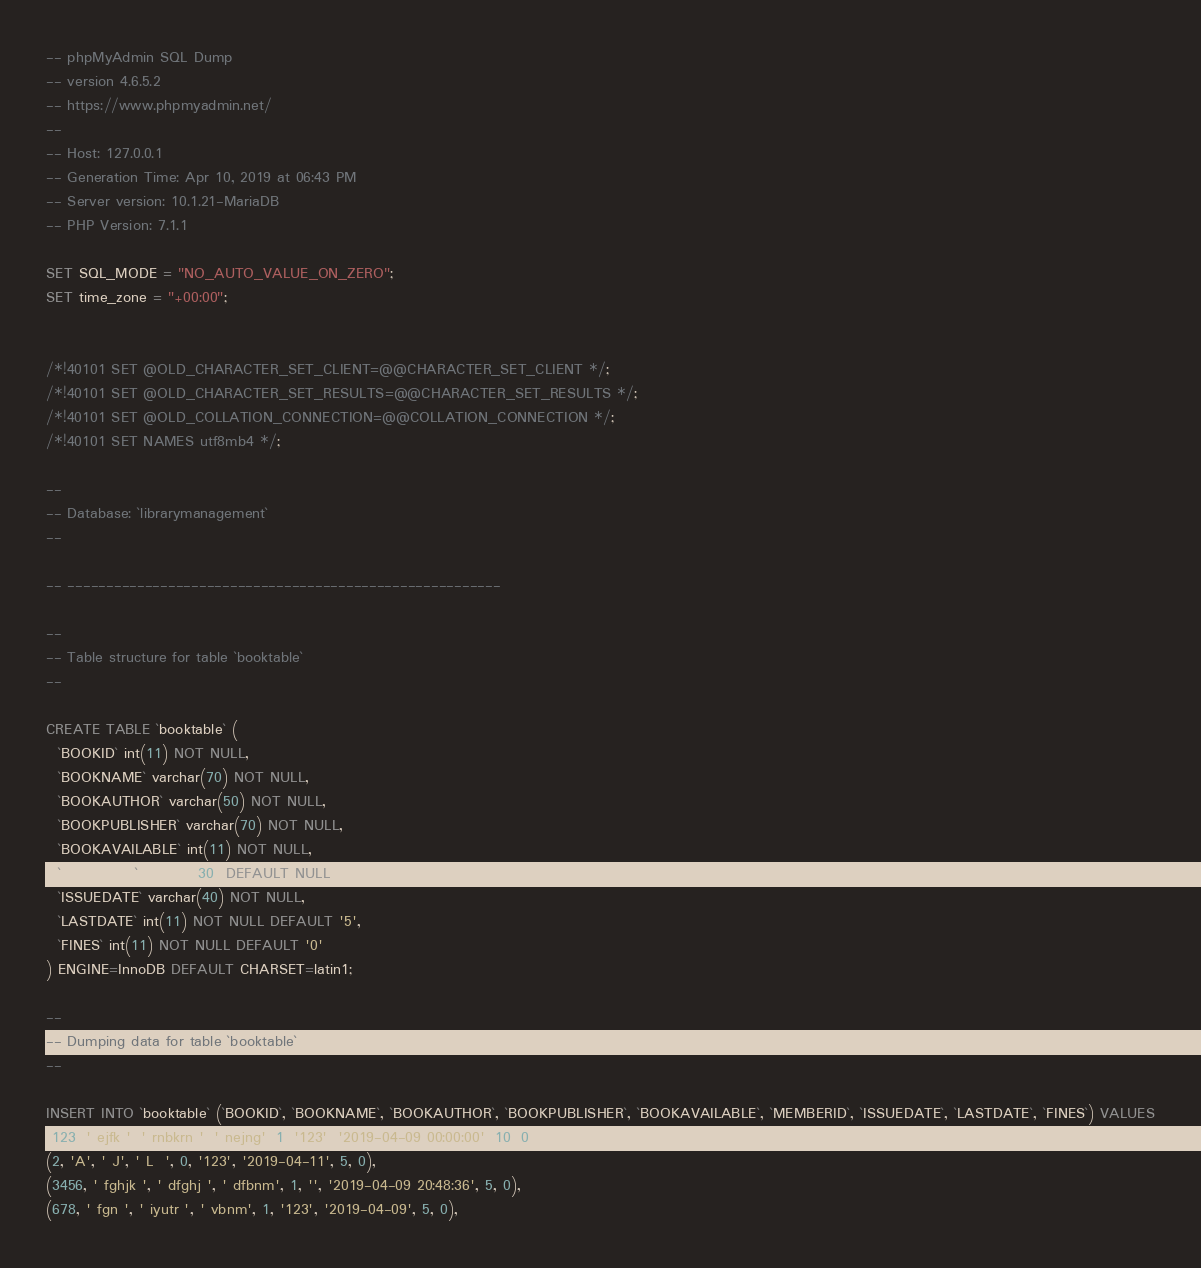<code> <loc_0><loc_0><loc_500><loc_500><_SQL_>-- phpMyAdmin SQL Dump
-- version 4.6.5.2
-- https://www.phpmyadmin.net/
--
-- Host: 127.0.0.1
-- Generation Time: Apr 10, 2019 at 06:43 PM
-- Server version: 10.1.21-MariaDB
-- PHP Version: 7.1.1

SET SQL_MODE = "NO_AUTO_VALUE_ON_ZERO";
SET time_zone = "+00:00";


/*!40101 SET @OLD_CHARACTER_SET_CLIENT=@@CHARACTER_SET_CLIENT */;
/*!40101 SET @OLD_CHARACTER_SET_RESULTS=@@CHARACTER_SET_RESULTS */;
/*!40101 SET @OLD_COLLATION_CONNECTION=@@COLLATION_CONNECTION */;
/*!40101 SET NAMES utf8mb4 */;

--
-- Database: `librarymanagement`
--

-- --------------------------------------------------------

--
-- Table structure for table `booktable`
--

CREATE TABLE `booktable` (
  `BOOKID` int(11) NOT NULL,
  `BOOKNAME` varchar(70) NOT NULL,
  `BOOKAUTHOR` varchar(50) NOT NULL,
  `BOOKPUBLISHER` varchar(70) NOT NULL,
  `BOOKAVAILABLE` int(11) NOT NULL,
  `MEMBERID` varchar(30) DEFAULT NULL,
  `ISSUEDATE` varchar(40) NOT NULL,
  `LASTDATE` int(11) NOT NULL DEFAULT '5',
  `FINES` int(11) NOT NULL DEFAULT '0'
) ENGINE=InnoDB DEFAULT CHARSET=latin1;

--
-- Dumping data for table `booktable`
--

INSERT INTO `booktable` (`BOOKID`, `BOOKNAME`, `BOOKAUTHOR`, `BOOKPUBLISHER`, `BOOKAVAILABLE`, `MEMBERID`, `ISSUEDATE`, `LASTDATE`, `FINES`) VALUES
(123, ' ejfk ', ' rnbkrn ', ' nejng', 1, '123', '2019-04-09 00:00:00', 10, 0),
(2, 'A', ' J', ' L  ', 0, '123', '2019-04-11', 5, 0),
(3456, ' fghjk ', ' dfghj ', ' dfbnm', 1, '', '2019-04-09 20:48:36', 5, 0),
(678, ' fgn ', ' iyutr ', ' vbnm', 1, '123', '2019-04-09', 5, 0),</code> 